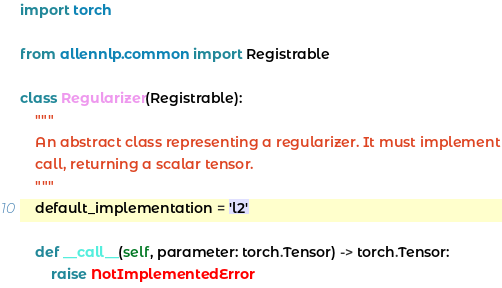Convert code to text. <code><loc_0><loc_0><loc_500><loc_500><_Python_>import torch

from allennlp.common import Registrable

class Regularizer(Registrable):
    """
    An abstract class representing a regularizer. It must implement
    call, returning a scalar tensor.
    """
    default_implementation = 'l2'

    def __call__(self, parameter: torch.Tensor) -> torch.Tensor:
        raise NotImplementedError
</code> 